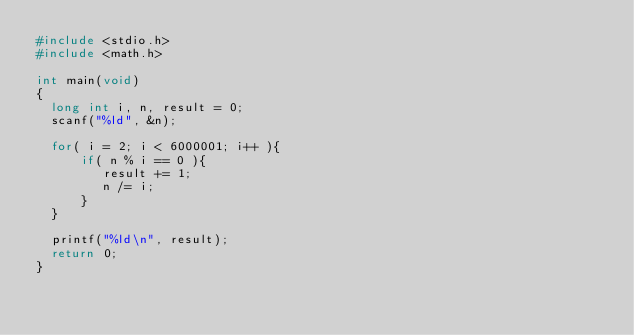<code> <loc_0><loc_0><loc_500><loc_500><_C_>#include <stdio.h>
#include <math.h>

int main(void)
{
  long int i, n, result = 0;
  scanf("%ld", &n);
  
  for( i = 2; i < 6000001; i++ ){
      if( n % i == 0 ){
         result += 1;
         n /= i;
      } 
  }
  
  printf("%ld\n", result);
  return 0;
}</code> 